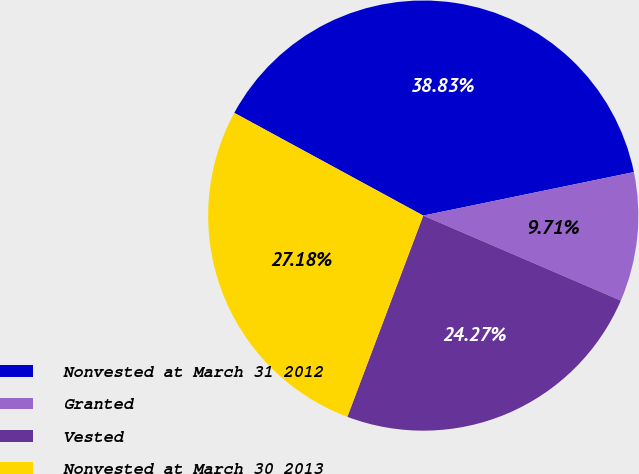Convert chart. <chart><loc_0><loc_0><loc_500><loc_500><pie_chart><fcel>Nonvested at March 31 2012<fcel>Granted<fcel>Vested<fcel>Nonvested at March 30 2013<nl><fcel>38.83%<fcel>9.71%<fcel>24.27%<fcel>27.18%<nl></chart> 